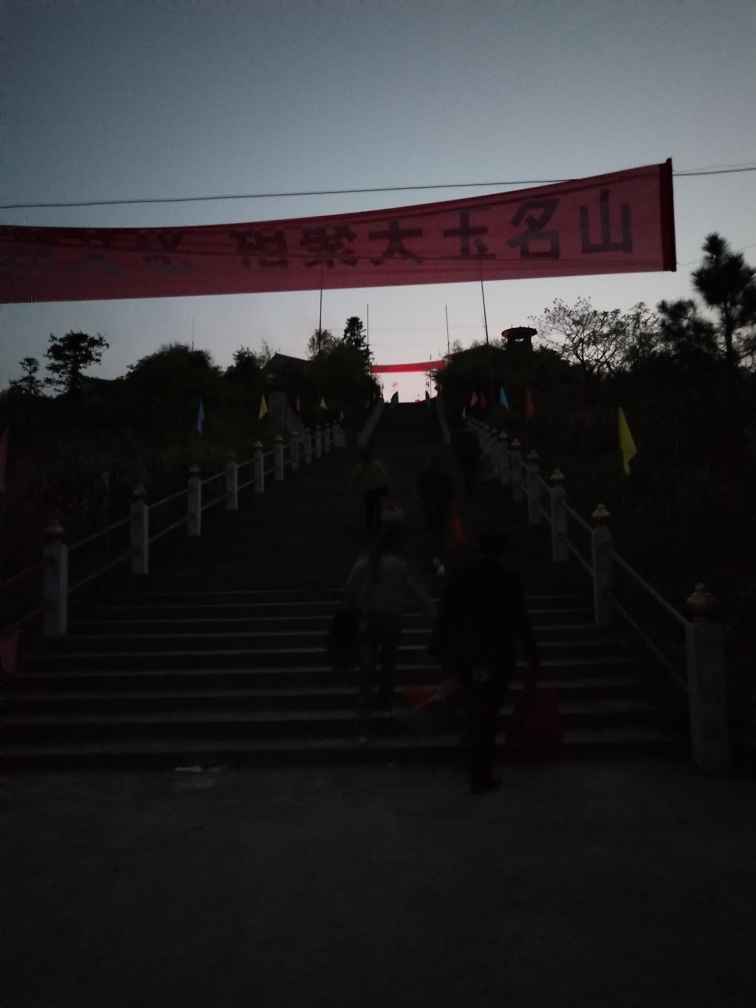What activities might be taking place in this image? Considering the image's context, with individuals climbing the stairs and the ceremonial-looking setup, it could be a public gathering, event, or procession of some sort. The presence of people holding objects that could be bags or equipment hints at an organized activity, possibly related to the event indicated by the banner. 